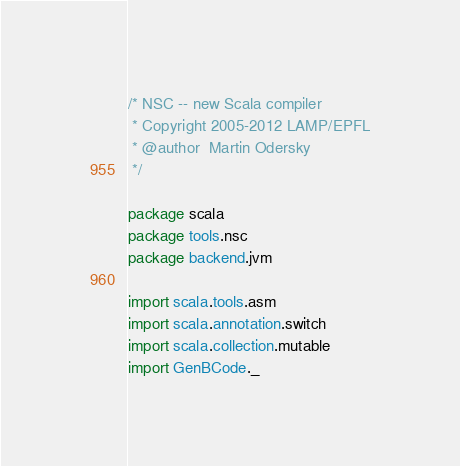<code> <loc_0><loc_0><loc_500><loc_500><_Scala_>/* NSC -- new Scala compiler
 * Copyright 2005-2012 LAMP/EPFL
 * @author  Martin Odersky
 */

package scala
package tools.nsc
package backend.jvm

import scala.tools.asm
import scala.annotation.switch
import scala.collection.mutable
import GenBCode._</code> 